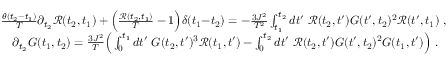Convert formula to latex. <formula><loc_0><loc_0><loc_500><loc_500>\begin{array} { r l } & { \, \frac { \theta ( t _ { 2 } { - } t _ { 1 } ) } { T } \partial _ { t _ { 2 } } \mathcal { R } ( t _ { 2 } , t _ { 1 } ) + \left ( \frac { \mathcal { R } ( t _ { 2 } , t _ { 1 } ) } { T } - 1 \right ) \delta ( t _ { 1 } { - } t _ { 2 } ) = - \frac { 3 J ^ { 2 } } { T ^ { 2 } } \int _ { t _ { 1 } } ^ { t _ { 2 } } d t ^ { \prime } \ \mathcal { R } ( t _ { 2 } , t ^ { \prime } ) G ( t ^ { \prime } , t _ { 2 } ) ^ { 2 } \mathcal { R } ( t ^ { \prime } , t _ { 1 } ) , } \\ & { \partial _ { t _ { 2 } } G ( t _ { 1 } , t _ { 2 } ) = \frac { 3 J ^ { 2 } } { T } \left ( \int _ { 0 } ^ { t _ { 1 } } d t ^ { \prime } \ G ( t _ { 2 } , t ^ { \prime } ) ^ { 3 } \mathcal { R } ( t _ { 1 } , t ^ { \prime } ) - \int _ { 0 } ^ { t _ { 2 } } d t ^ { \prime } \ \mathcal { R } ( t _ { 2 } , t ^ { \prime } ) G ( t ^ { \prime } , t _ { 2 } ) ^ { 2 } G ( t _ { 1 } , t ^ { \prime } ) \right ) . } \end{array}</formula> 